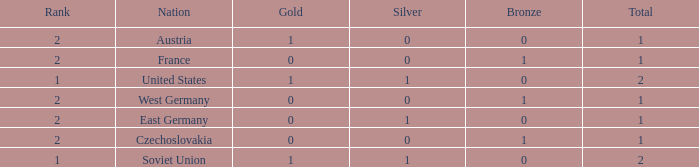What is the highest rank of Austria, which had less than 0 silvers? None. 